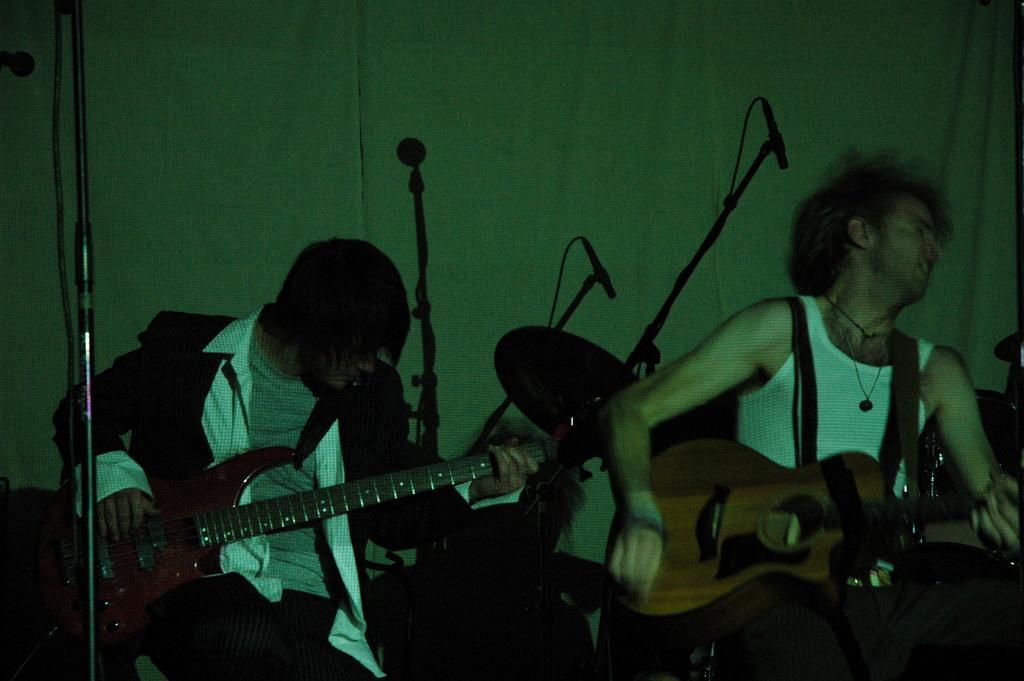Could you give a brief overview of what you see in this image? In the image there are two men playing guitar. In front of them there is pole and in the background of them there is mic stands and drum kit. 